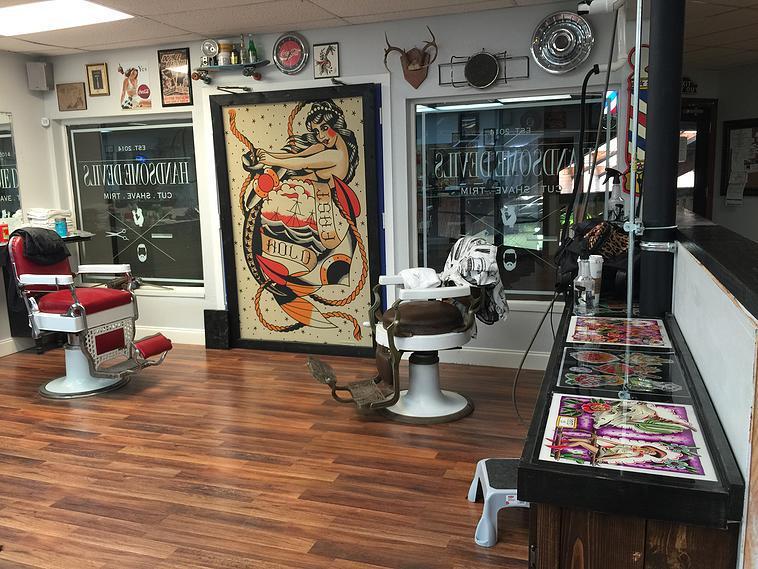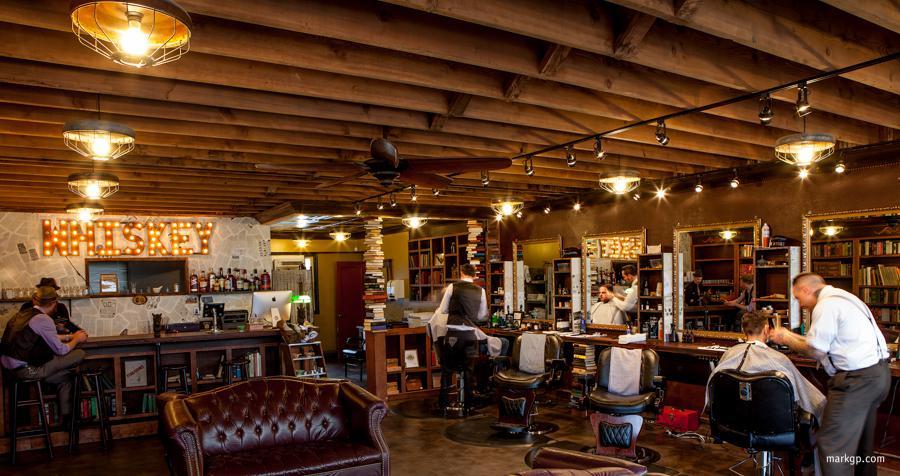The first image is the image on the left, the second image is the image on the right. For the images displayed, is the sentence "At least four round lights hang from the ceiling in one of the images." factually correct? Answer yes or no. Yes. 